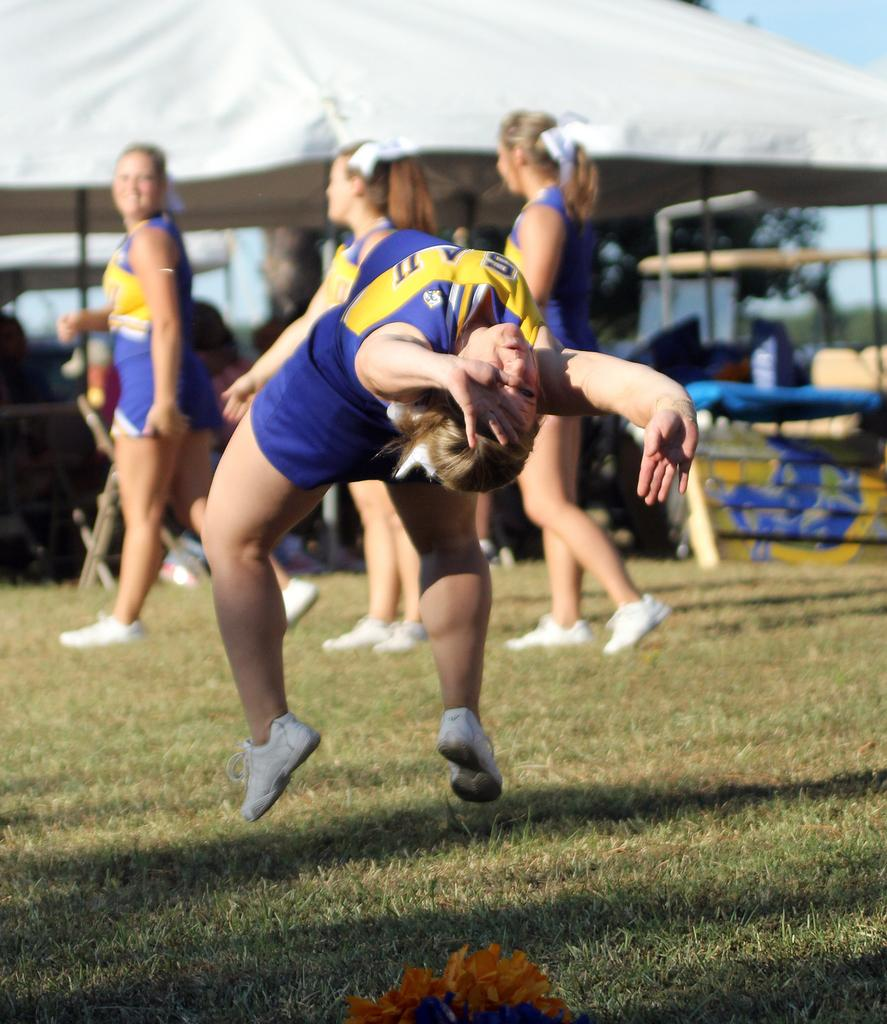What are the people in the image doing? The people in the image are walking on the ground. Is there any other action being performed by someone in the image? Yes, a person is jumping in the image. What structure can be seen in the image? There is a tent in the image. What is the purpose of the iron pole in the image? The iron pole is likely used to support the tent or other structures. What can be found on the ground in the image? There are objects on the ground in the image. What is visible in the background of the image? The sky is visible in the image. What type of leather is being offered to the person in the image? There is no leather or offering present in the image; it only shows people walking, a person jumping, a tent, an iron pole, objects on the ground, and the sky. 